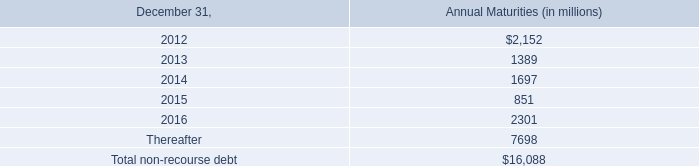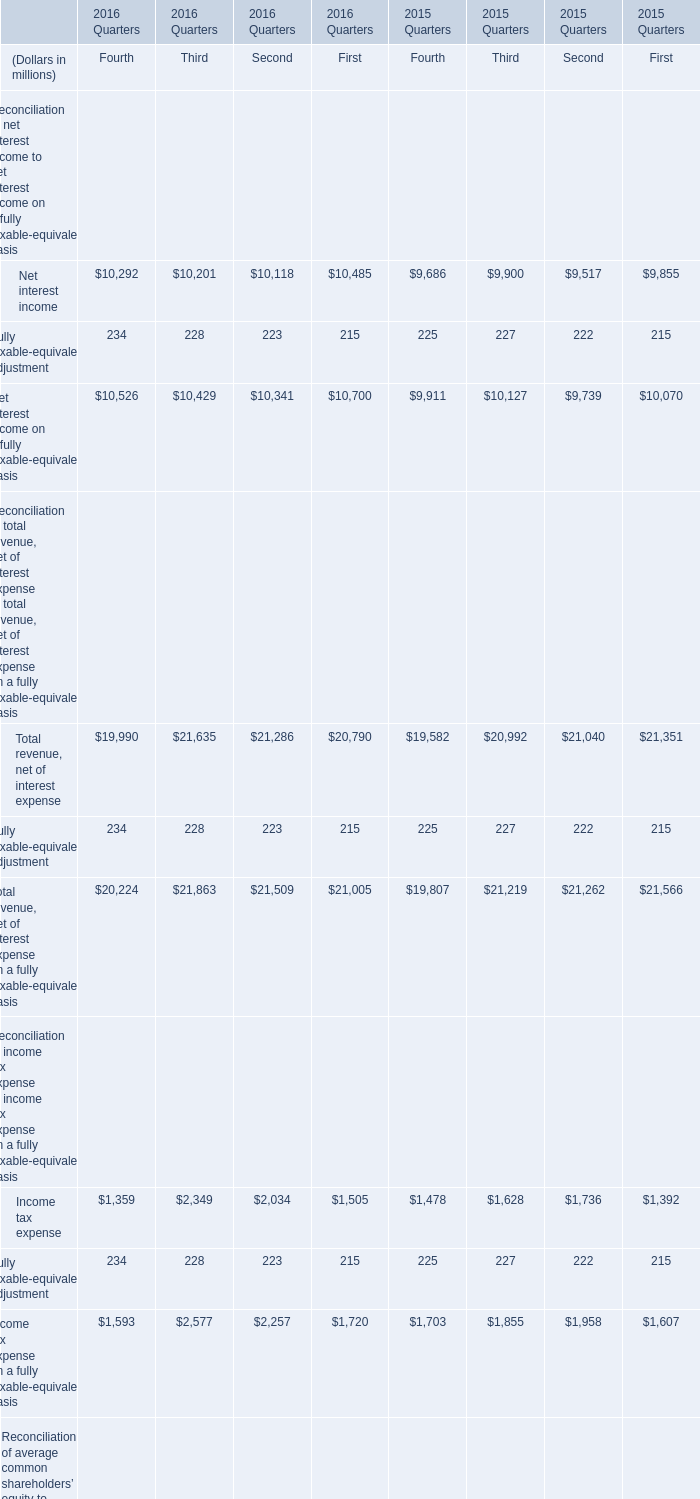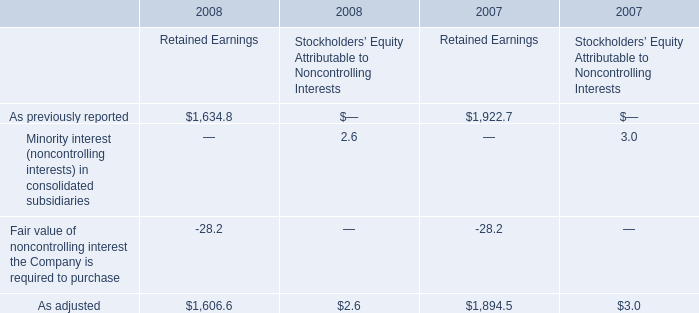If Net interest income develops with the same growth rate in Fourth Quarter, 2016, what will it reach in First Quarter, 2017? (in million) 
Computations: (10292 + ((10292 * (10292 - 10201)) / 10201))
Answer: 10383.81178. 